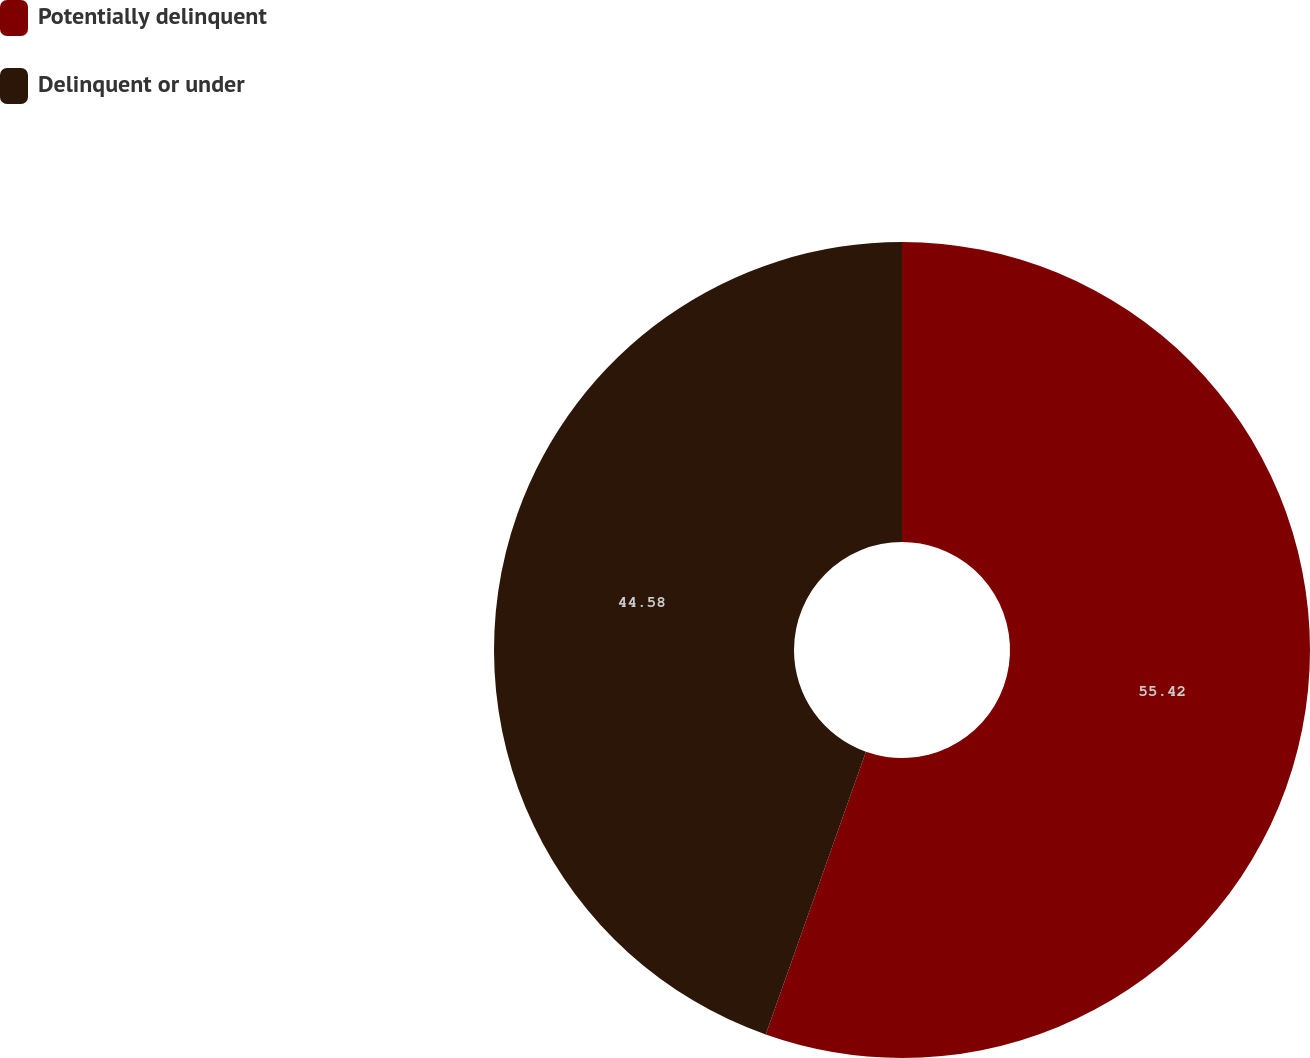<chart> <loc_0><loc_0><loc_500><loc_500><pie_chart><fcel>Potentially delinquent<fcel>Delinquent or under<nl><fcel>55.42%<fcel>44.58%<nl></chart> 